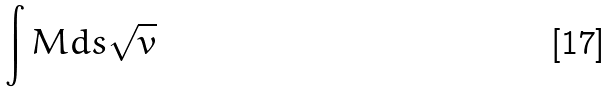Convert formula to latex. <formula><loc_0><loc_0><loc_500><loc_500>\int M d s \sqrt { v }</formula> 